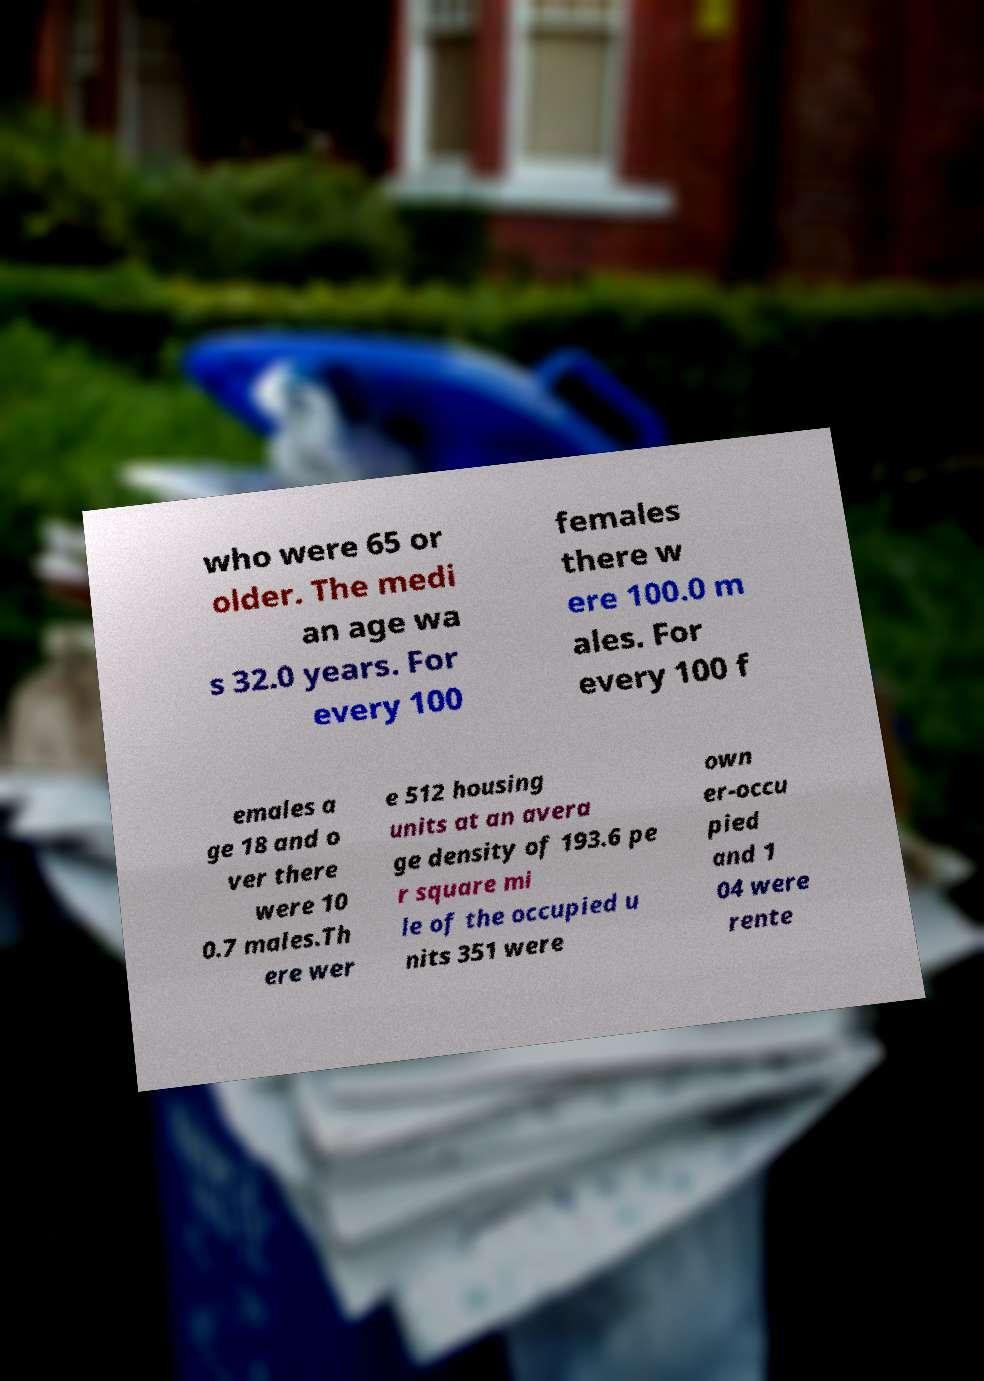Please read and relay the text visible in this image. What does it say? who were 65 or older. The medi an age wa s 32.0 years. For every 100 females there w ere 100.0 m ales. For every 100 f emales a ge 18 and o ver there were 10 0.7 males.Th ere wer e 512 housing units at an avera ge density of 193.6 pe r square mi le of the occupied u nits 351 were own er-occu pied and 1 04 were rente 